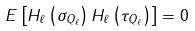<formula> <loc_0><loc_0><loc_500><loc_500>E \left [ H _ { \ell } \left ( \sigma _ { Q _ { \ell } } \right ) H _ { \ell } \left ( \tau _ { Q _ { \ell } } \right ) \right ] = 0</formula> 